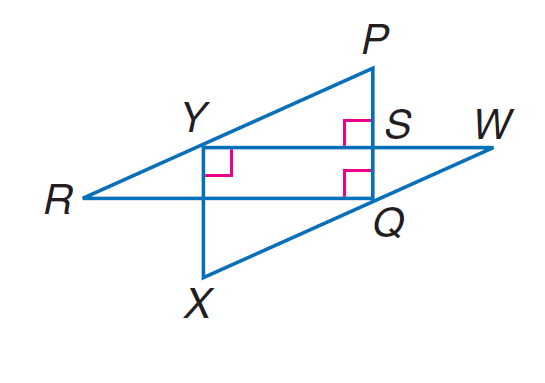Answer the mathemtical geometry problem and directly provide the correct option letter.
Question: If P R \parallel W X, W X = 10, X Y = 6, W Y = 8, R Y = 5, and P S = 3, find P Q.
Choices: A: 5.5 B: 6 C: 8 D: 11 B 